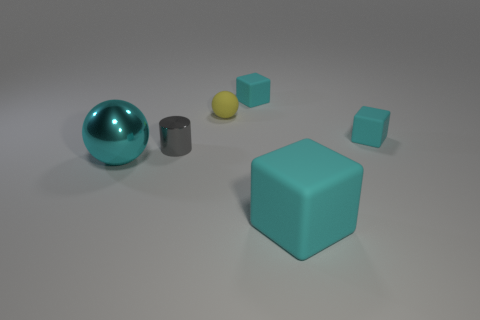Subtract all cyan cubes. How many were subtracted if there are2cyan cubes left? 1 Subtract all small matte cubes. How many cubes are left? 1 Subtract 2 cubes. How many cubes are left? 1 Add 4 tiny cubes. How many objects exist? 10 Subtract all yellow balls. How many balls are left? 1 Subtract all yellow blocks. How many cyan balls are left? 1 Add 2 yellow matte balls. How many yellow matte balls exist? 3 Subtract 0 purple cylinders. How many objects are left? 6 Subtract all spheres. How many objects are left? 4 Subtract all cyan balls. Subtract all green cylinders. How many balls are left? 1 